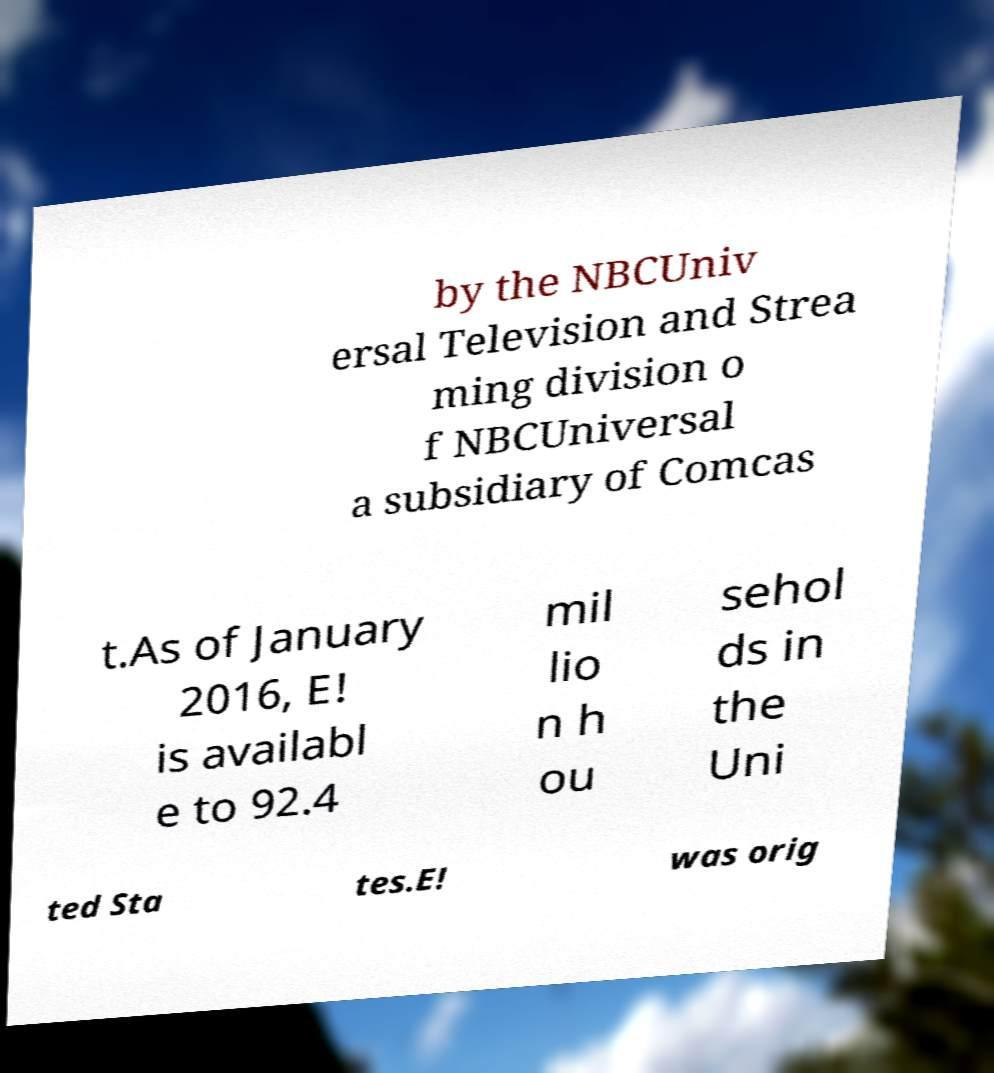Please identify and transcribe the text found in this image. by the NBCUniv ersal Television and Strea ming division o f NBCUniversal a subsidiary of Comcas t.As of January 2016, E! is availabl e to 92.4 mil lio n h ou sehol ds in the Uni ted Sta tes.E! was orig 